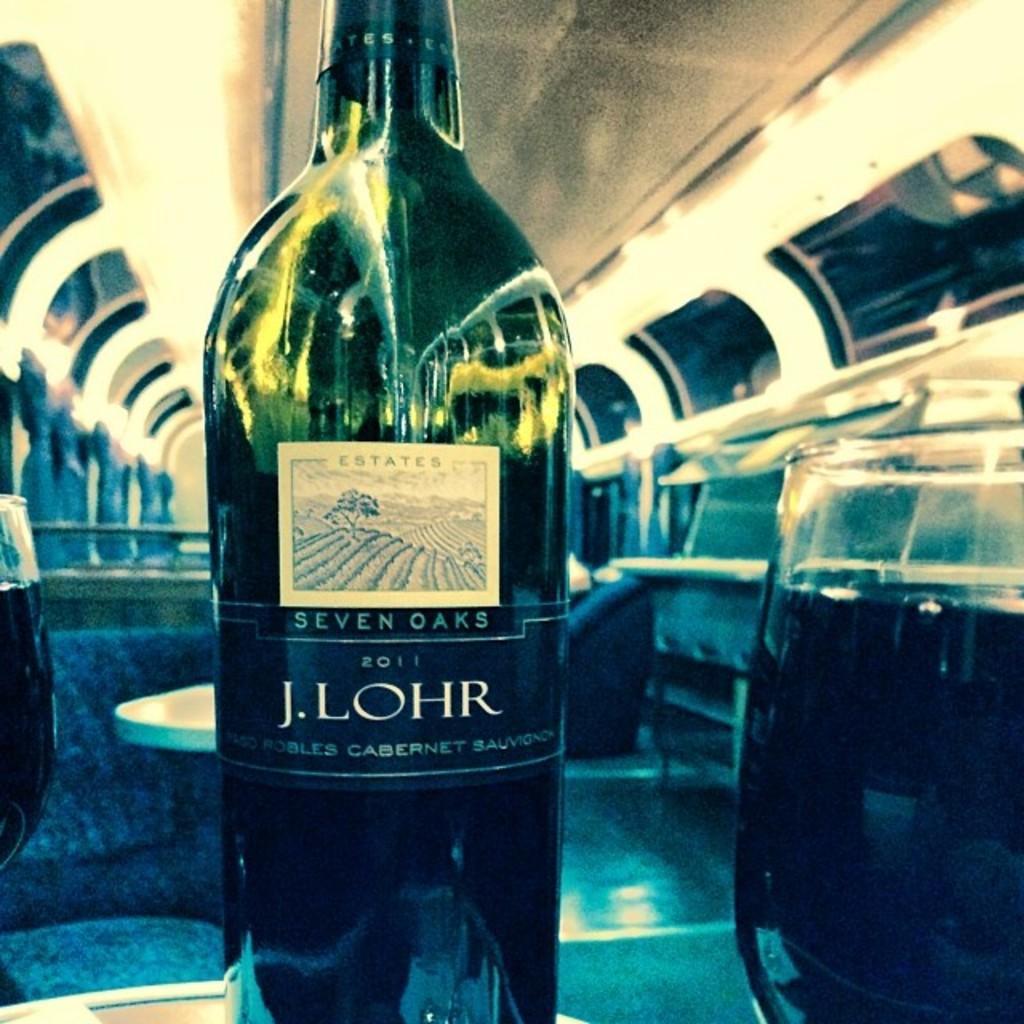Please provide a concise description of this image. In this image there is a bottle and two glasses. There is a table at the back. 